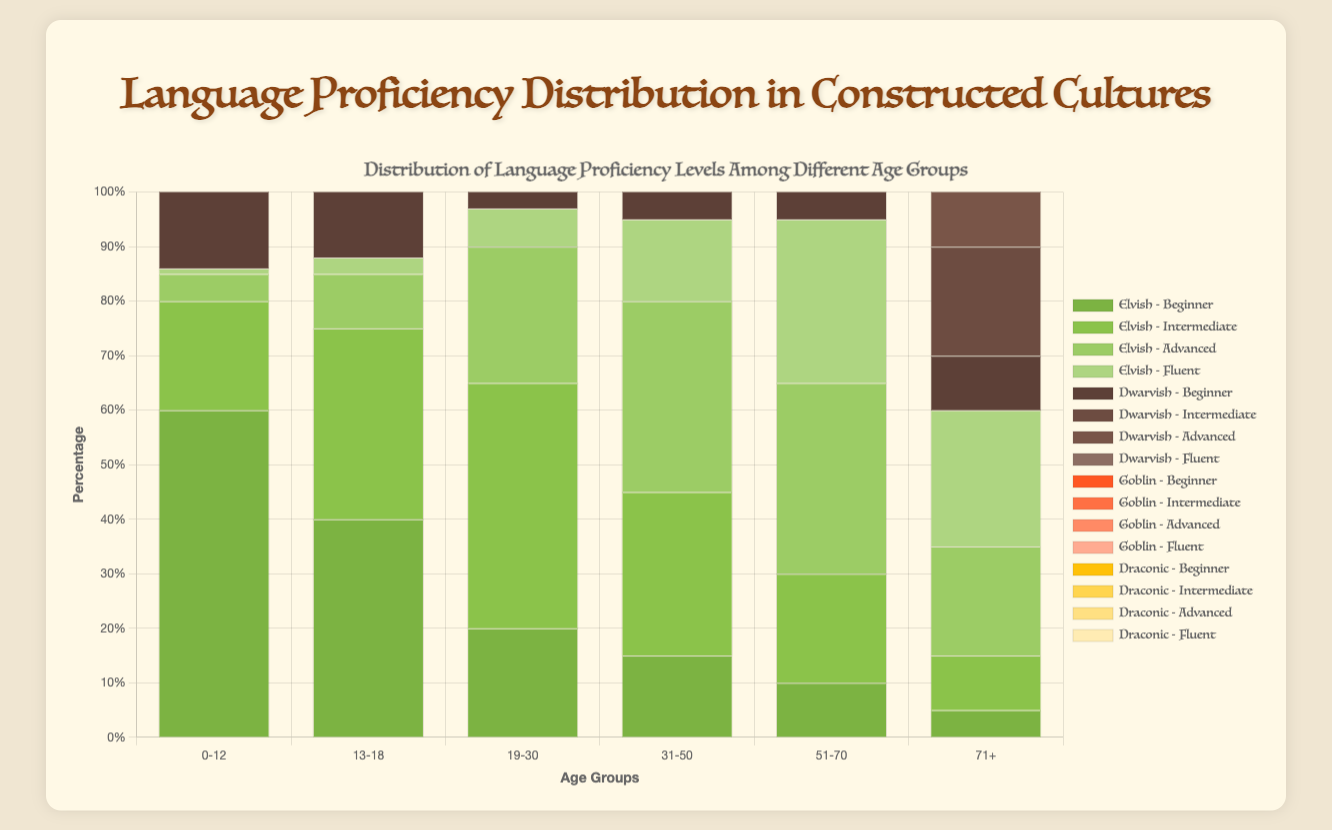Which age group has the highest percentage of people fluent in Elvish? First, look for the group of bars representing "Fluent" in Elvish. Identify the tallest bar, which corresponds to the 51-70 age group with 30%.
Answer: 51-70 Which language shows the highest percentage of beginners in the 0-12 age group? For the 0-12 group, compare the bars representing "Beginner" for each language. The tallest beginner bar is Goblin with 80%.
Answer: Goblin Compare the percentage of people with advanced proficiency in Draconic between the 19-30 and 31-50 age groups. Identify the bars for "Advanced" in Draconic for the 19-30 and 31-50 age groups. The heights show 25% and 30% respectively, so the percentage is higher in the 31-50 group.
Answer: 31-50 For Dwarvish, which age group has more intermediate-level speakers, 19-30 or 51-70? Identify the "Intermediate" bars for Dwarvish in the 19-30 and 51-70 groups. The 19-30 group bar is at 40%, and the 51-70 group bar is at 30%. 19-30 has more intermediate speakers.
Answer: 19-30 In the 71+ age group, which language has the highest percentage of fluent speakers? Look at the "Fluent" bars within the 71+ age group. Compare their heights: Elvish (25%), Dwarvish (15%), Goblin (10%), Draconic (20%). Elvish has the highest with 25%.
Answer: Elvish What is the average percentage of fluent speakers across all age groups for Goblin? Sum the percentages of fluent Goblin speakers across all groups: (0 + 0.5 + 2 + 5 + 10 + 10) = 27. Divide by the number of age groups: 27/6 = 4.5%.
Answer: 4.5% Which age group has the smallest percentage of intermediate Elvish speakers? Check the "Intermediate" bars for Elvish across all age groups. The smallest percentage is for the 0-12 group with 20%.
Answer: 0-12 Determine the difference in the percentage of advanced Draconic speakers between the 51-70 and 71+ age groups. Identify the "Advanced" Draconic bars for both age groups: 51-70 (40%) and 71+ (25%). The difference is 40% - 25% = 15%.
Answer: 15% In the 31-50 age group, which language has the highest percentage of advanced speakers? Look at the "Advanced" bars for each language within the 31-50 group. Compare their heights: Elvish (35%), Dwarvish (25%), Goblin (25%), Draconic (30%). Elvish has the highest with 35%.
Answer: Elvish Across all age groups, which language shows a consistent increase in the percentage of fluent speakers? Analyze the "Fluent" bars for a consistent upward trend. Elvish (1% to 25%) shows an increase, while others have fluctuations.
Answer: Elvish 